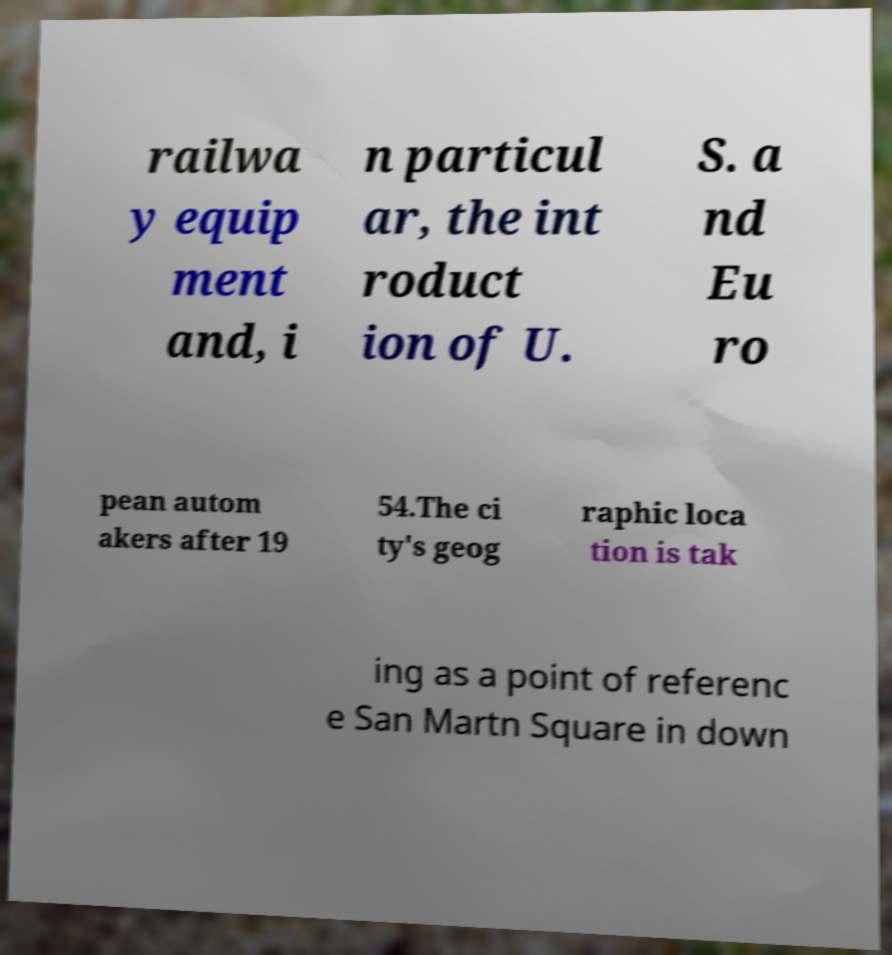Could you assist in decoding the text presented in this image and type it out clearly? railwa y equip ment and, i n particul ar, the int roduct ion of U. S. a nd Eu ro pean autom akers after 19 54.The ci ty's geog raphic loca tion is tak ing as a point of referenc e San Martn Square in down 